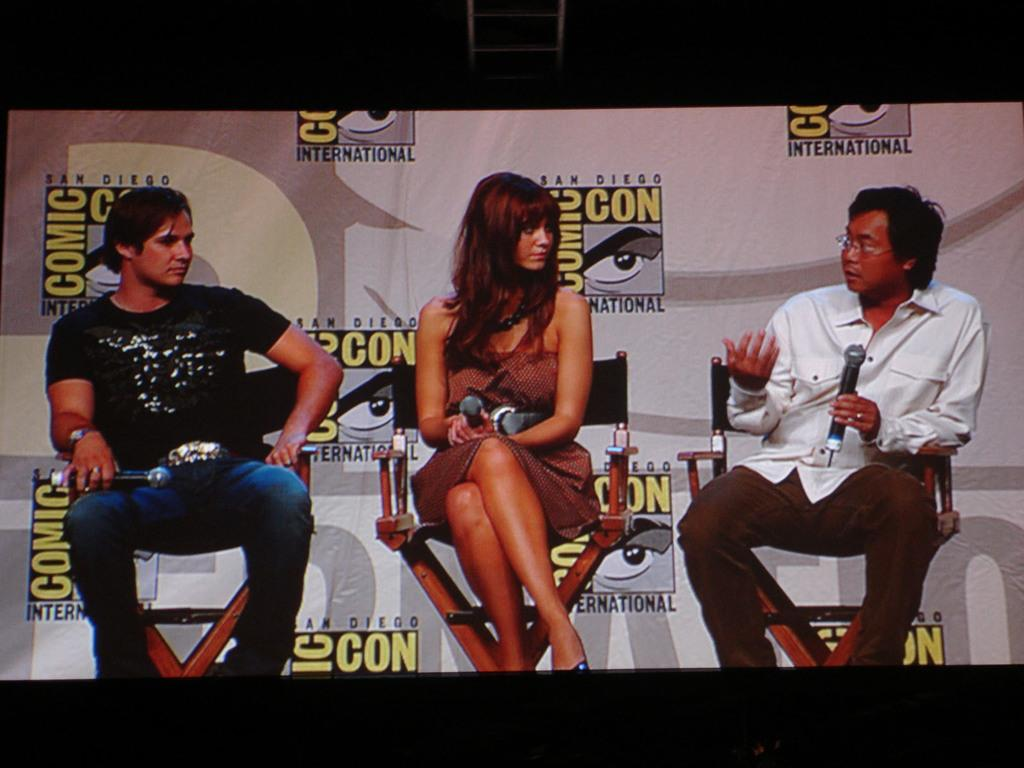How many people are in the image? There are three persons in the image. What are the persons doing in the image? The persons are sitting on chairs and holding microphones. What else can be seen in the image besides the persons? There is a banner visible in the image. Can you tell me how many feet are visible in the image? There is no mention of feet or any body parts in the image, so it's not possible to determine how many feet are visible. 